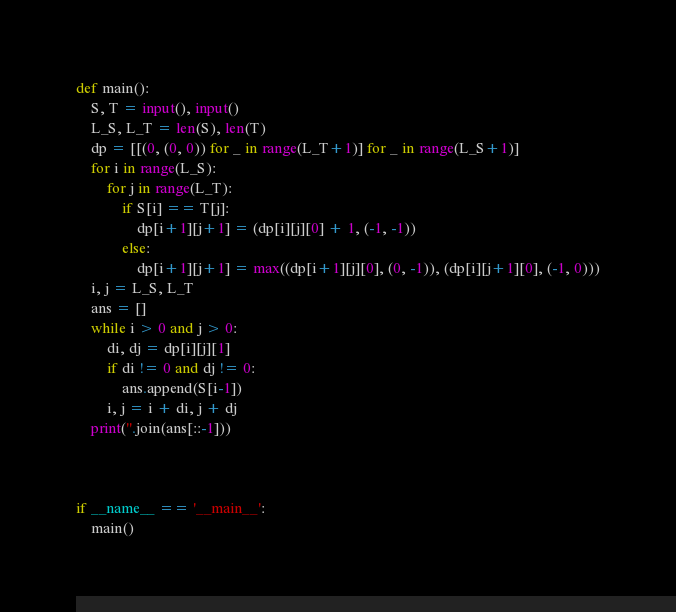<code> <loc_0><loc_0><loc_500><loc_500><_Python_>def main():
    S, T = input(), input()
    L_S, L_T = len(S), len(T)
    dp = [[(0, (0, 0)) for _ in range(L_T+1)] for _ in range(L_S+1)]
    for i in range(L_S):
        for j in range(L_T):
            if S[i] == T[j]:
                dp[i+1][j+1] = (dp[i][j][0] + 1, (-1, -1))
            else:
                dp[i+1][j+1] = max((dp[i+1][j][0], (0, -1)), (dp[i][j+1][0], (-1, 0)))
    i, j = L_S, L_T
    ans = []
    while i > 0 and j > 0:
        di, dj = dp[i][j][1]
        if di != 0 and dj != 0:
            ans.append(S[i-1])
        i, j = i + di, j + dj
    print(''.join(ans[::-1]))



if __name__ == '__main__':
    main()
</code> 